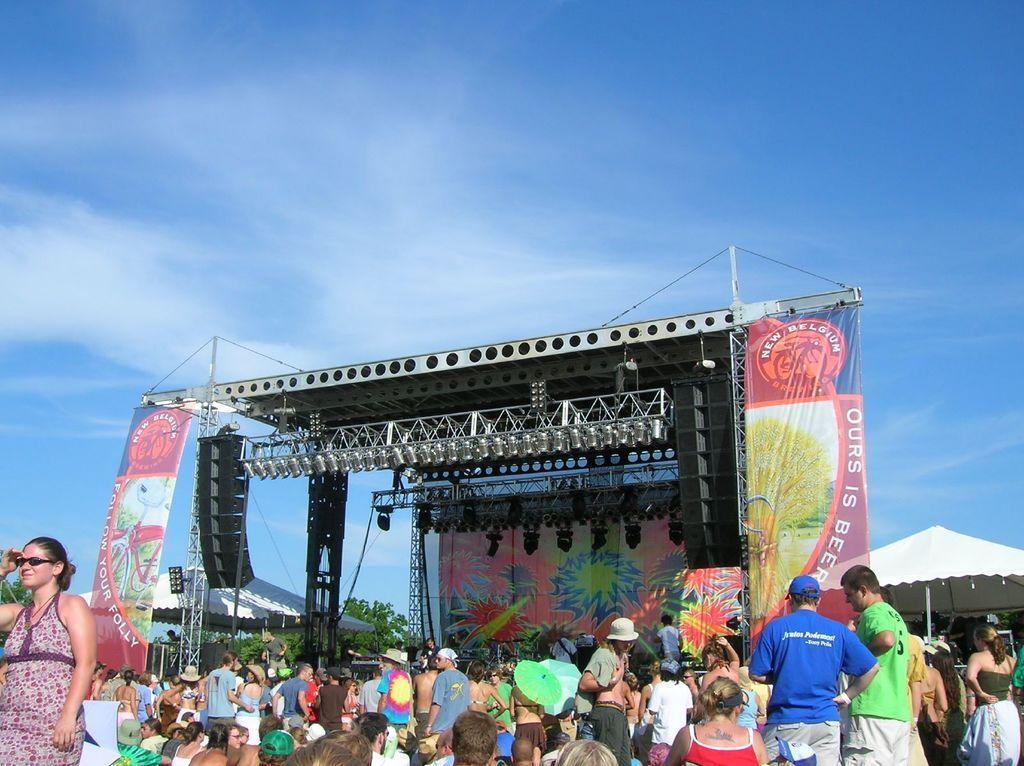How would you summarize this image in a sentence or two? In the center of the image, we can see a stage and there are banners, lights and stands and we can see people and some are wearing caps and there are tents and we can see trees. At the top, there are clouds in the sky. 